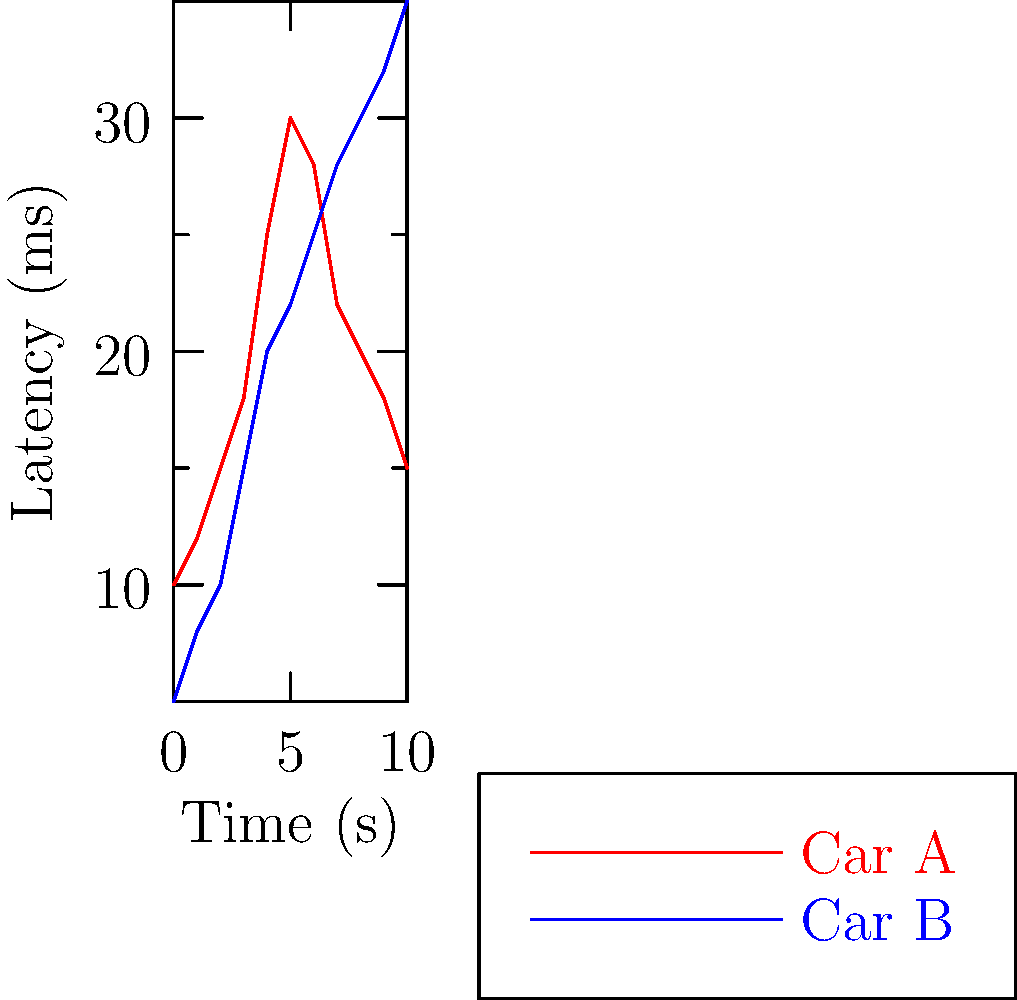Based on the network latency graph for two race cars' telemetry systems, which car is likely experiencing a more stable connection to the pit crew's monitoring system during the 10-second interval shown? To determine which car has a more stable connection, we need to analyze the latency trends for both cars:

1. Car A (red line):
   - Starts at 10ms latency
   - Increases to a peak of 30ms at around 5 seconds
   - Decreases back to 15ms by the end of the 10-second interval
   - Shows significant fluctuations in latency

2. Car B (blue line):
   - Starts at 5ms latency
   - Gradually increases to 35ms by the end of the 10-second interval
   - Shows a more consistent, gradual increase in latency

3. Stability analysis:
   - Car A's latency varies more dramatically, with sharp increases and decreases
   - Car B's latency increases more steadily, without sudden spikes or drops

4. Impact on telemetry:
   - Stable connections are crucial for consistent data transmission
   - Sudden changes in latency can lead to data loss or delayed information

5. Conclusion:
   Although Car B ends with higher latency, its more gradual and predictable increase suggests a more stable connection throughout the measured interval.
Answer: Car B 